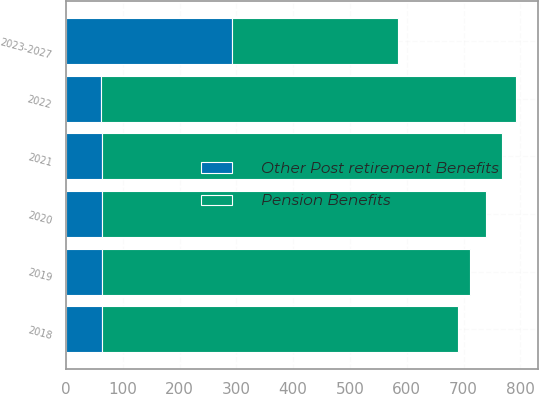Convert chart to OTSL. <chart><loc_0><loc_0><loc_500><loc_500><stacked_bar_chart><ecel><fcel>2018<fcel>2019<fcel>2020<fcel>2021<fcel>2022<fcel>2023-2027<nl><fcel>Pension Benefits<fcel>626<fcel>648<fcel>676<fcel>704<fcel>730<fcel>292<nl><fcel>Other Post retirement Benefits<fcel>64<fcel>64<fcel>63<fcel>63<fcel>62<fcel>292<nl></chart> 